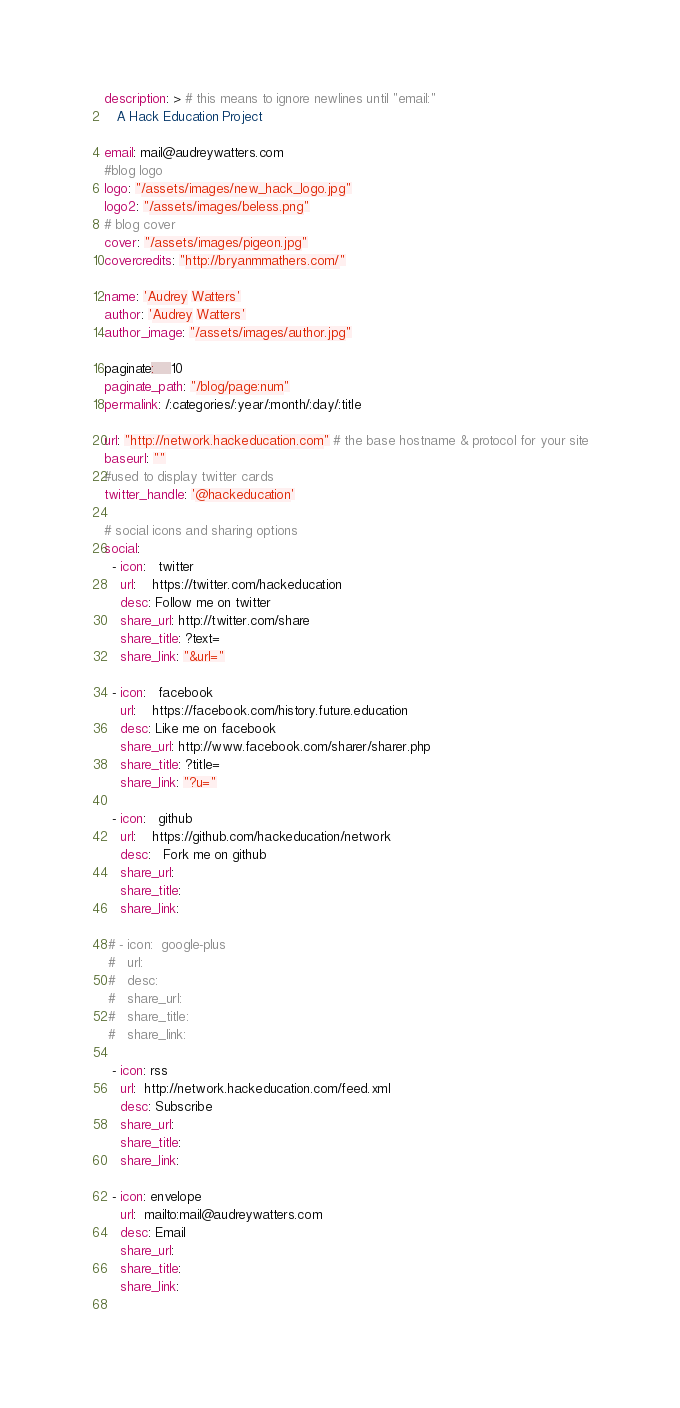<code> <loc_0><loc_0><loc_500><loc_500><_YAML_>description: > # this means to ignore newlines until "email:"
   A Hack Education Project

email: mail@audreywatters.com
#blog logo
logo: "/assets/images/new_hack_logo.jpg"
logo2: "/assets/images/beless.png"
# blog cover
cover: "/assets/images/pigeon.jpg"
covercredits: "http://bryanmmathers.com/"

name: 'Audrey Watters'
author: 'Audrey Watters'
author_image: "/assets/images/author.jpg"

paginate:	10
paginate_path: "/blog/page:num"
permalink: /:categories/:year/:month/:day/:title 

url: "http://network.hackeducation.com" # the base hostname & protocol for your site
baseurl: ""
#used to display twitter cards
twitter_handle: '@hackeducation'

# social icons and sharing options
social:
  - icon:   twitter
    url:    https://twitter.com/hackeducation
    desc: Follow me on twitter
    share_url: http://twitter.com/share
    share_title: ?text=
    share_link: "&url="

  - icon:   facebook
    url:    https://facebook.com/history.future.education
    desc: Like me on facebook
    share_url: http://www.facebook.com/sharer/sharer.php
    share_title: ?title=
    share_link: "?u="

  - icon:   github
    url:    https://github.com/hackeducation/network
    desc:   Fork me on github
    share_url: 
    share_title:
    share_link:

 # - icon:  google-plus
 #   url:   
 #   desc:  
 #   share_url:
 #   share_title:
 #   share_link:

  - icon: rss
    url:  http://network.hackeducation.com/feed.xml
    desc: Subscribe
    share_url:
    share_title:
    share_link:

  - icon: envelope
    url:  mailto:mail@audreywatters.com
    desc: Email
    share_url:
    share_title:
    share_link:    
  

</code> 